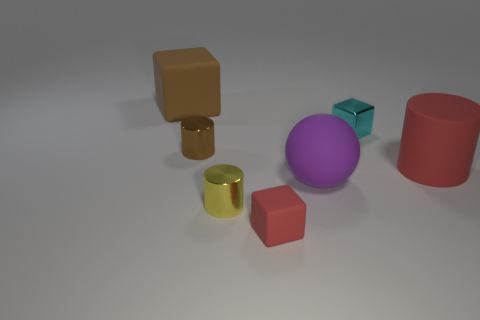There is a big object on the left side of the matte cube that is right of the matte object left of the tiny yellow shiny object; what color is it?
Give a very brief answer. Brown. Are the large red cylinder and the big thing that is in front of the big red matte object made of the same material?
Offer a very short reply. Yes. What size is the cyan metallic object that is the same shape as the small matte thing?
Your answer should be very brief. Small. Is the number of small cyan metallic things that are behind the brown block the same as the number of small yellow shiny objects that are behind the large cylinder?
Offer a very short reply. Yes. How many other objects are the same material as the cyan cube?
Offer a very short reply. 2. Are there an equal number of red rubber cubes that are on the right side of the big purple thing and brown cylinders?
Ensure brevity in your answer.  No. There is a purple thing; is its size the same as the rubber cube that is behind the small red matte block?
Provide a short and direct response. Yes. There is a matte object that is left of the tiny red cube; what shape is it?
Offer a terse response. Cube. Is there any other thing that has the same shape as the big red object?
Keep it short and to the point. Yes. Are there any tiny gray matte cylinders?
Ensure brevity in your answer.  No. 